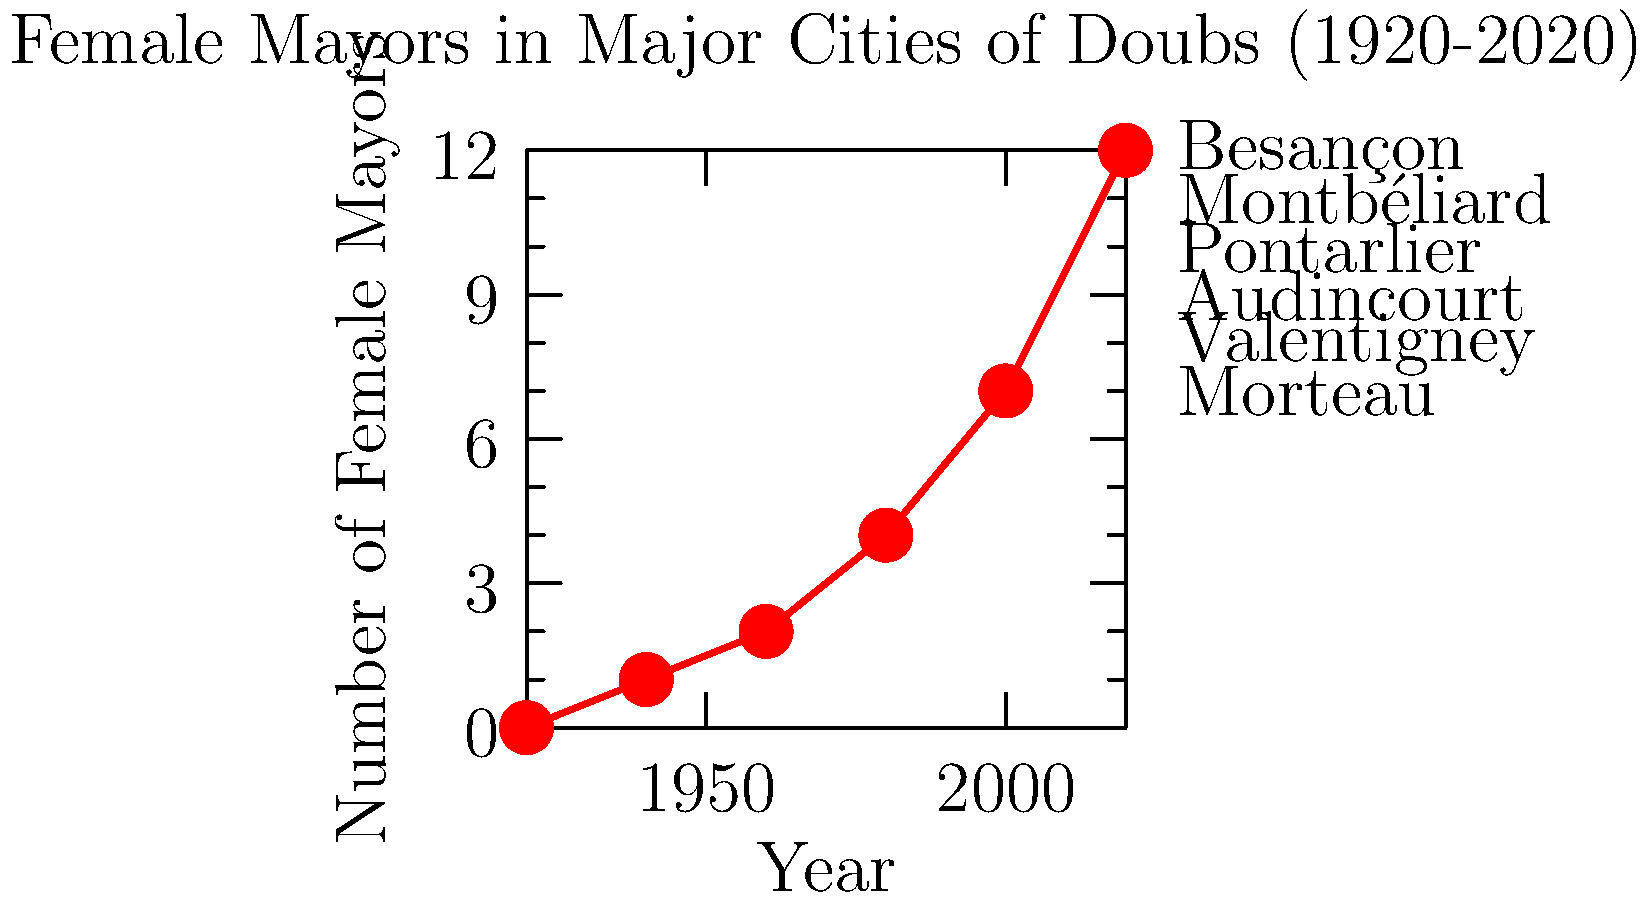Based on the graph showing the number of female mayors in major cities of Doubs from 1920 to 2020, what significant trend can be observed, and how does this relate to the broader context of women's political participation in France? To answer this question, we need to analyze the graph and consider the historical context:

1. Observe the trend: The graph shows a clear upward trend in the number of female mayors from 1920 to 2020.

2. Identify key points:
   - In 1920, there were no female mayors in the major cities of Doubs.
   - By 1940, there was only one female mayor.
   - The number steadily increased over the decades.
   - By 2020, there were 12 female mayors in the major cities of Doubs.

3. Calculate the rate of change: The number of female mayors increased from 0 to 12 over a century, showing a significant growth.

4. Historical context:
   - Women in France gained the right to vote and stand for election in 1944.
   - The graph shows a slight increase in female mayors after 1940, which aligns with this historical event.

5. Broader implications:
   - The trend reflects the gradual increase in women's political participation in France.
   - It demonstrates the progress made in gender equality in local politics in the Doubs region.

6. Comparison to national trends:
   - This local trend in Doubs mirrors the national trend of increasing female political representation in France.

The significant trend observed is a steady increase in female mayors over the century, reflecting the broader context of women's growing political participation in France, particularly after gaining suffrage in 1944.
Answer: Steady increase in female mayors, reflecting growing women's political participation in France post-1944 suffrage. 